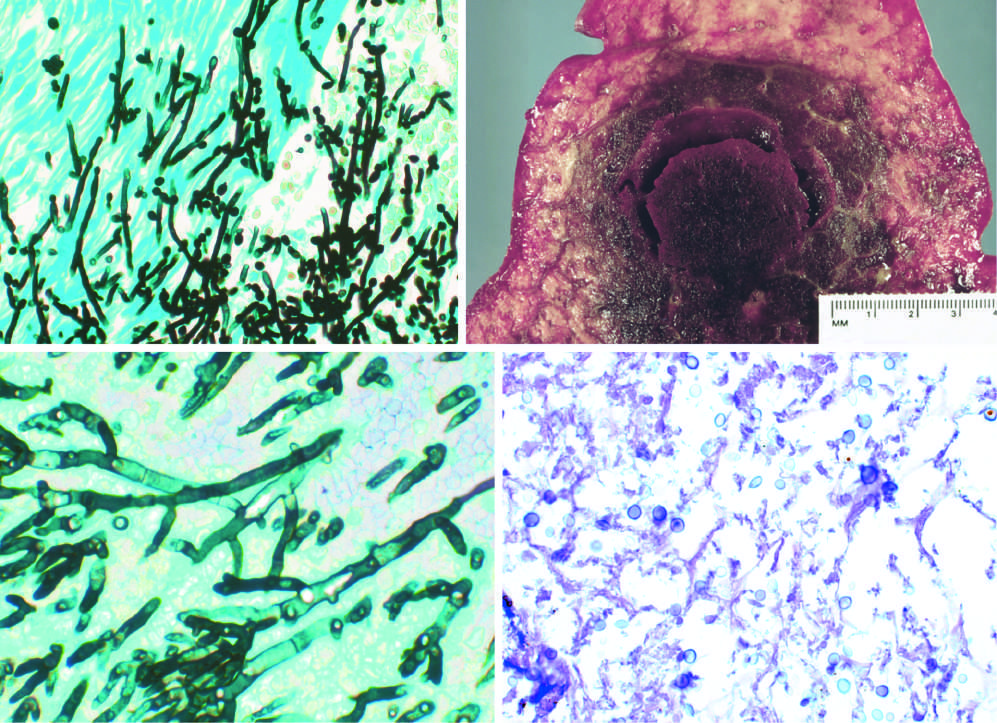re the organisms somewhat variable in size?
Answer the question using a single word or phrase. Yes 